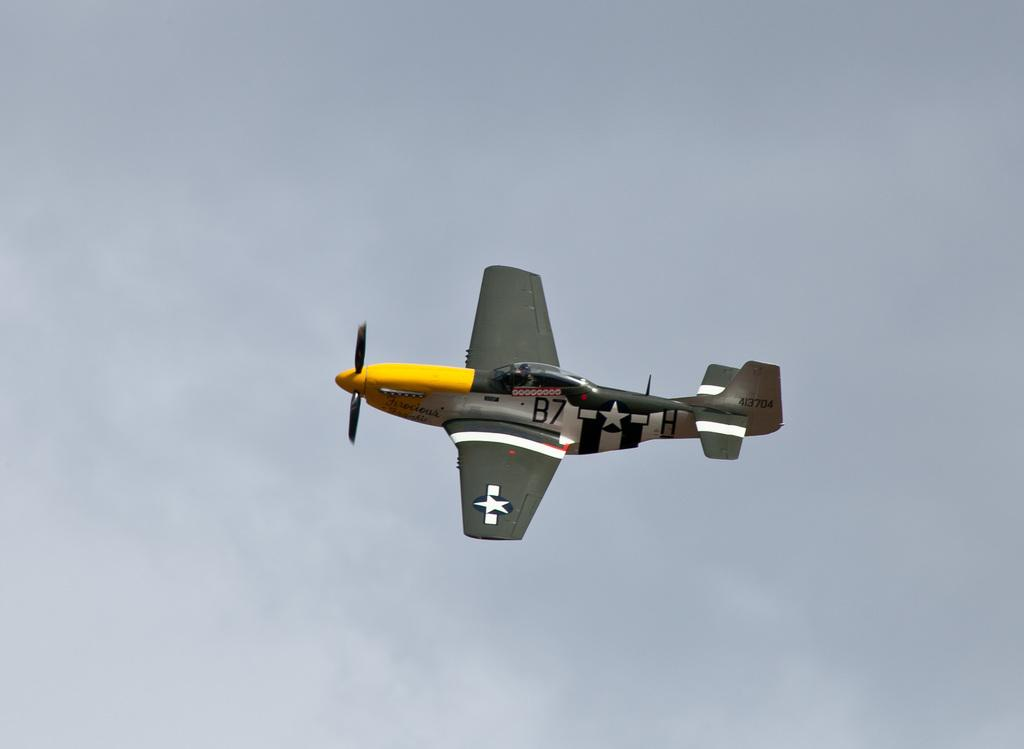<image>
Describe the image concisely. a b7 airplane in the sky all alone 